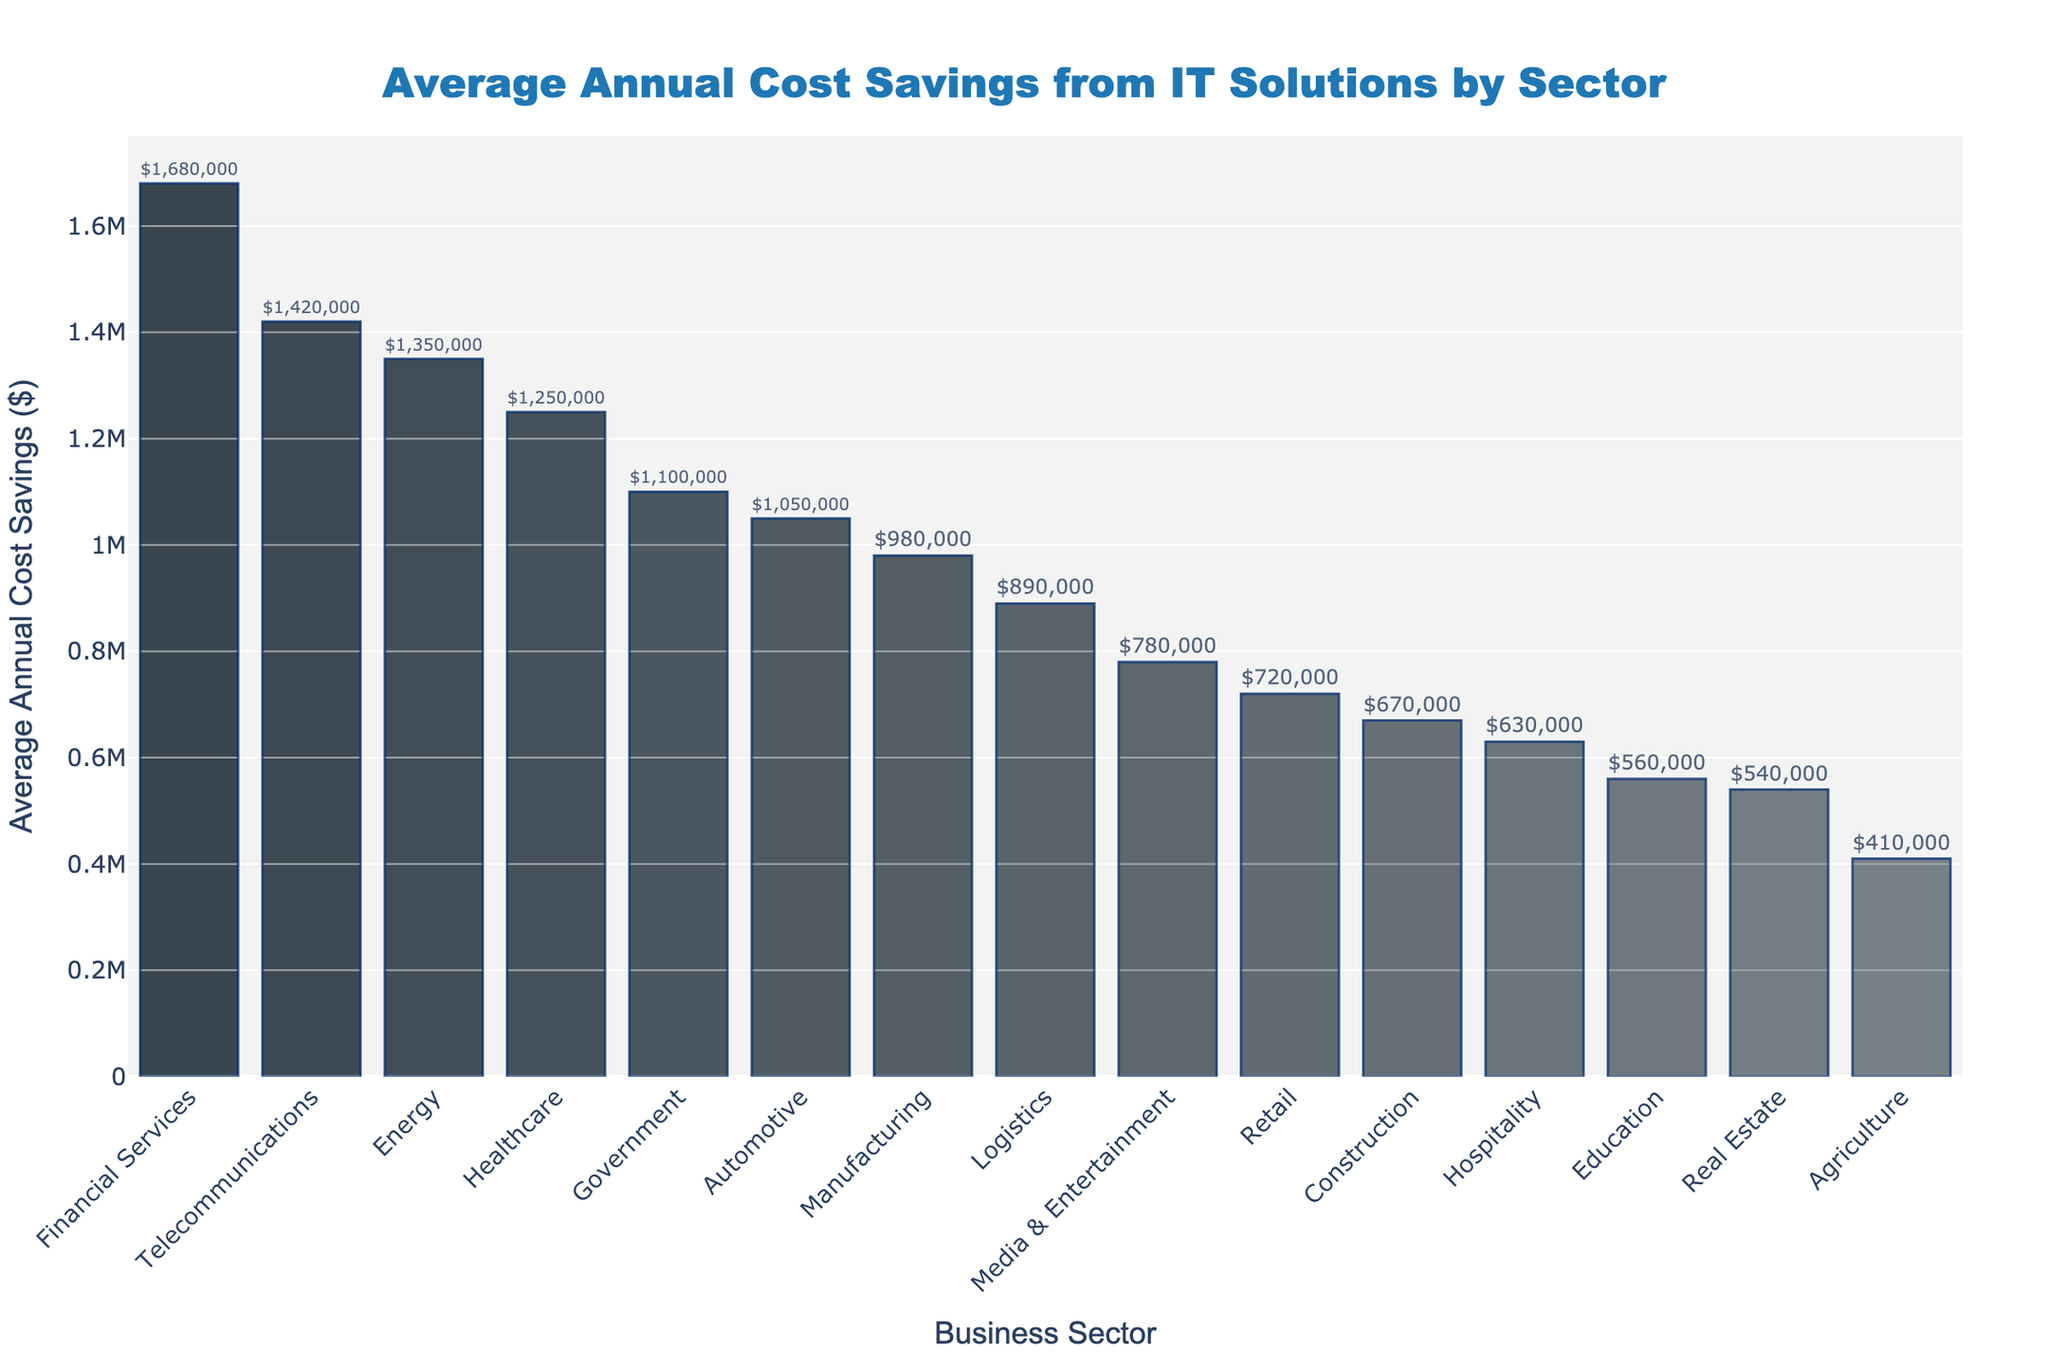what's the average annual cost savings for the top three sectors? To find the average, identify the top three sectors: Financial Services ($1,680,000), Telecommunications ($1,420,000), and Energy ($1,350,000). The sum is $1,680,000 + $1,420,000 + $1,350,000 = $4,450,000. Divide by 3: $4,450,000 / 3 = $1,483,333.33
Answer: $1,483,333.33 which sector has the highest average annual cost savings? Look at the bar heights and identify the highest one, which corresponds to Financial Services.
Answer: Financial Services how much more cost does the Manufacturing sector save compared to the Retail sector? Find Manufacturing's annual savings ($980,000), and Retail's annual savings ($720,000). Subtract Retail's savings from Manufacturing's: $980,000 - $720,000 = $260,000
Answer: $260,000 what is the difference in average annual cost savings between Energy and Government sectors? Find the savings for Energy ($1,350,000) and Government ($1,100,000). Subtract Government's from Energy's: $1,350,000 - $1,100,000 = $250,000
Answer: $250,000 which sector is between Logistics and Healthcare in terms of cost savings? Order the sectors based on savings and find Logistics ($890,000) and Healthcare ($1,250,000). Government at $1,100,000 is between them.
Answer: Government how many sectors save more than $1,000,000 annually? Count the bars higher than $1,000,000. The sectors are Financial Services, Telecommunications, Energy, Healthcare, Government, and Automotive, totaling 6.
Answer: 6 which sector has the lowest average annual cost savings? Identify the shortest bar, which corresponds to Agriculture with $410,000.
Answer: Agriculture what is the combined average annual cost savings of Retail, Hospitality, and Construction? Add Retail ($720,000), Hospitality ($630,000), and Construction ($670,000): $720,000 + $630,000 + $670,000 = $2,020,000
Answer: $2,020,000 which is larger, the average cost savings of the Real Estate sector or the combined savings of Education and Agriculture? Compare Real Estate ($540,000) with the sum of Education ($560,000) and Agriculture ($410,000): $560,000 + $410,000 = $970,000. $540,000 is less than $970,000.
Answer: Combined savings of Education and Agriculture what is the average annual cost savings for sectors that save under $1,000,000? Identify the sectors under $1,000,000: Manufacturing ($980,000), Retail ($720,000), Education ($560,000), Logistics ($890,000), Hospitality ($630,000), Media & Entertainment ($780,000), Agriculture ($410,000), Construction ($670,000), Real Estate ($540,000). Sum their savings: $980,000 + $720,000 + $560,000 + $890,000 + $630,000 + $780,000 + $410,000 + $670,000 + $540,000 = $6,180,000. Divide by 9: $6,180,000 / 9 = $686,666.67
Answer: $686,666.67 